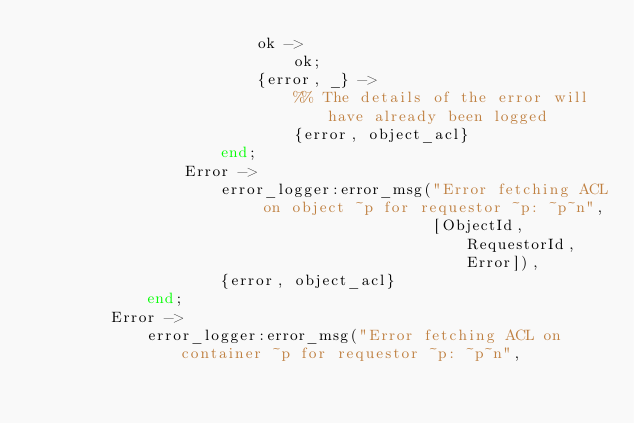Convert code to text. <code><loc_0><loc_0><loc_500><loc_500><_Erlang_>                        ok ->
                            ok;
                        {error, _} ->
                            %% The details of the error will have already been logged
                            {error, object_acl}
                    end;
                Error ->
                    error_logger:error_msg("Error fetching ACL on object ~p for requestor ~p: ~p~n",
                                           [ObjectId, RequestorId, Error]),
                    {error, object_acl}
            end;
        Error ->
            error_logger:error_msg("Error fetching ACL on container ~p for requestor ~p: ~p~n",</code> 